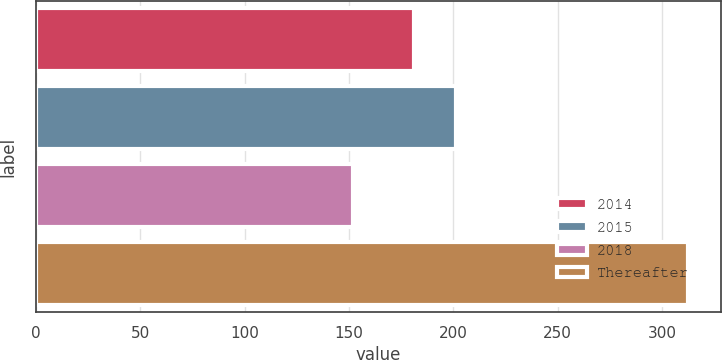<chart> <loc_0><loc_0><loc_500><loc_500><bar_chart><fcel>2014<fcel>2015<fcel>2018<fcel>Thereafter<nl><fcel>181.1<fcel>201.4<fcel>152.2<fcel>312.5<nl></chart> 